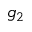Convert formula to latex. <formula><loc_0><loc_0><loc_500><loc_500>g _ { 2 }</formula> 